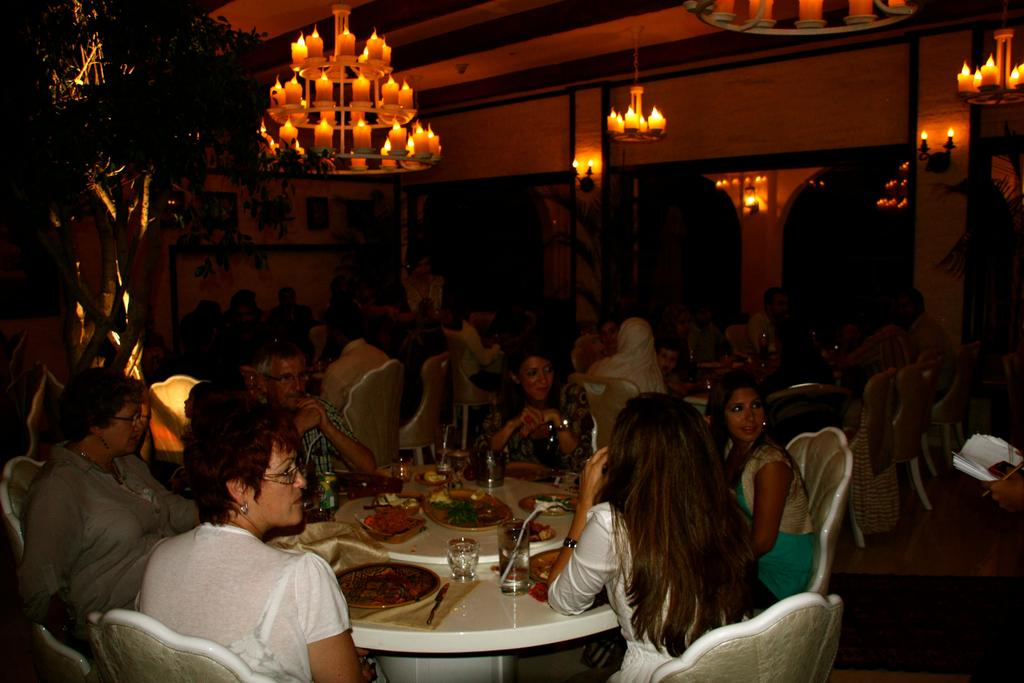What is happening in the image involving a group of people? There is a group of people in the image, and they are seated on chairs. What can be seen on the table in the image? There are food items and glasses on the table. Is there any lighting fixture visible in the image? Yes, there is a chandelier light on the table. What is the name of the person causing destruction in the image? There is no destruction or person causing destruction in the image. 